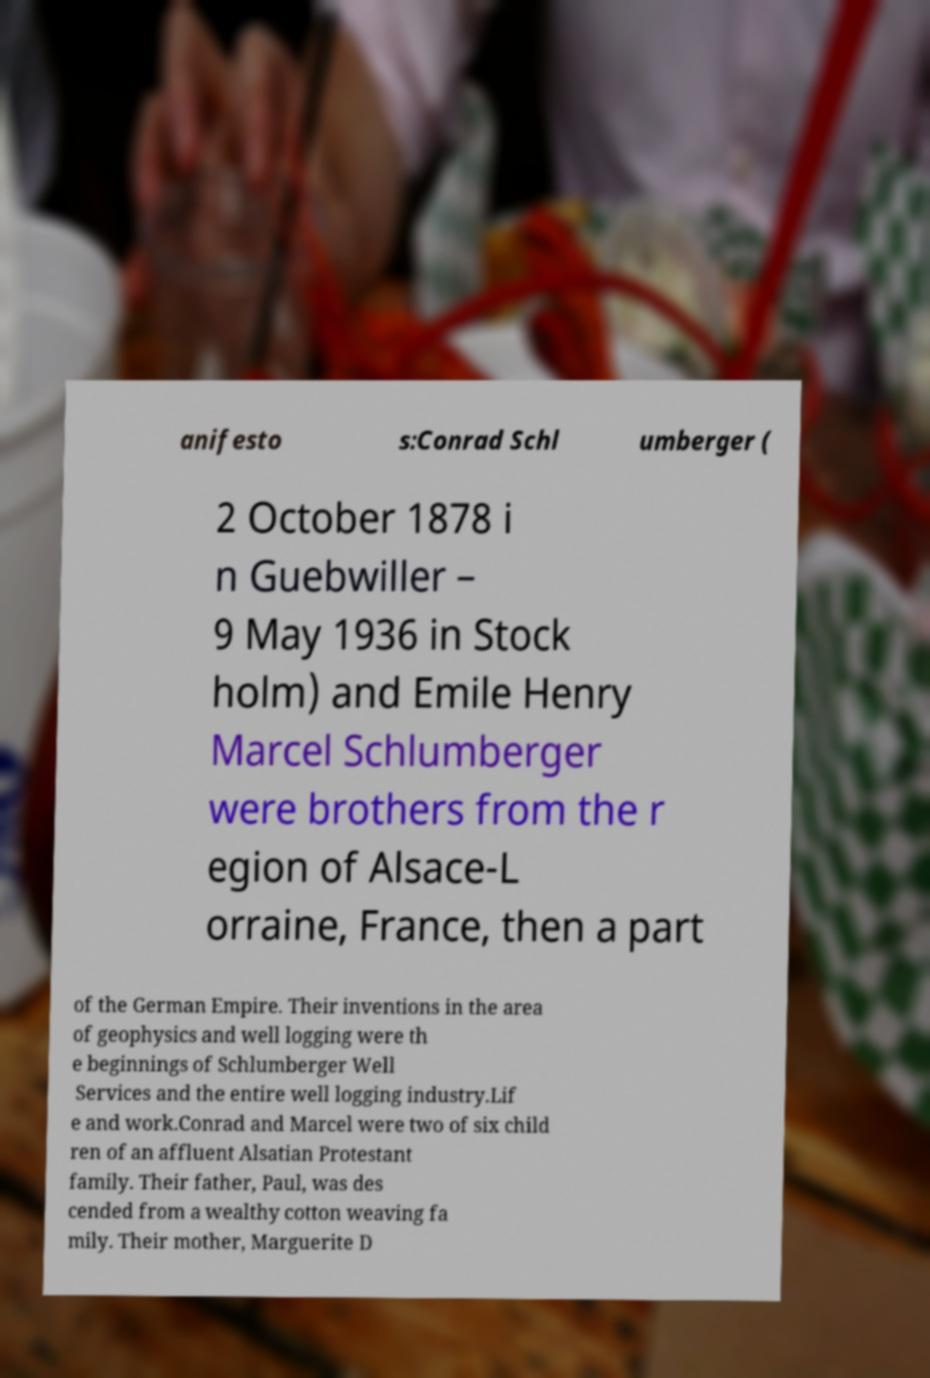For documentation purposes, I need the text within this image transcribed. Could you provide that? anifesto s:Conrad Schl umberger ( 2 October 1878 i n Guebwiller – 9 May 1936 in Stock holm) and Emile Henry Marcel Schlumberger were brothers from the r egion of Alsace-L orraine, France, then a part of the German Empire. Their inventions in the area of geophysics and well logging were th e beginnings of Schlumberger Well Services and the entire well logging industry.Lif e and work.Conrad and Marcel were two of six child ren of an affluent Alsatian Protestant family. Their father, Paul, was des cended from a wealthy cotton weaving fa mily. Their mother, Marguerite D 